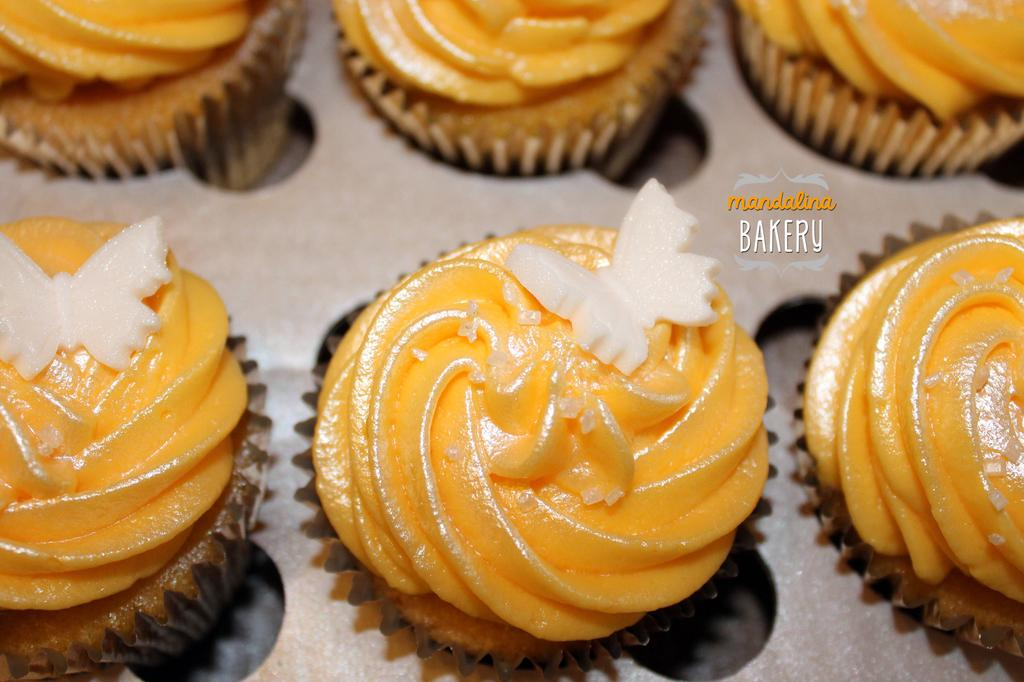What type of items are visible in the image? There are food items in the image. Where are the food items located? The food items are on an object. Is there any additional information about the image itself? Yes, there is a watermark on the image. Can you hear any bells ringing in the image? There are no bells present in the image, and therefore no ringing can be heard. 